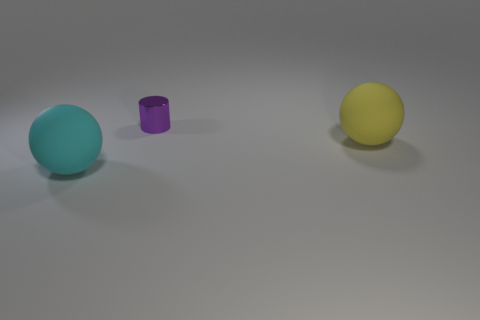Is there any other thing that is made of the same material as the large cyan thing?
Your answer should be very brief. Yes. Does the rubber sphere behind the cyan thing have the same size as the cyan rubber sphere?
Your answer should be very brief. Yes. Is there a large matte object of the same color as the metal object?
Provide a short and direct response. No. There is a matte thing to the left of the metallic cylinder; is there a large yellow rubber ball that is in front of it?
Your answer should be compact. No. Is there a tiny purple thing that has the same material as the big yellow thing?
Provide a succinct answer. No. What material is the sphere on the right side of the large rubber thing that is in front of the large yellow matte thing made of?
Give a very brief answer. Rubber. The thing that is in front of the tiny thing and behind the cyan object is made of what material?
Your response must be concise. Rubber. Are there the same number of small objects behind the yellow ball and cyan things?
Your response must be concise. Yes. How many other rubber objects have the same shape as the yellow matte object?
Give a very brief answer. 1. There is a ball that is behind the sphere on the left side of the rubber sphere right of the small metal object; what is its size?
Offer a very short reply. Large. 